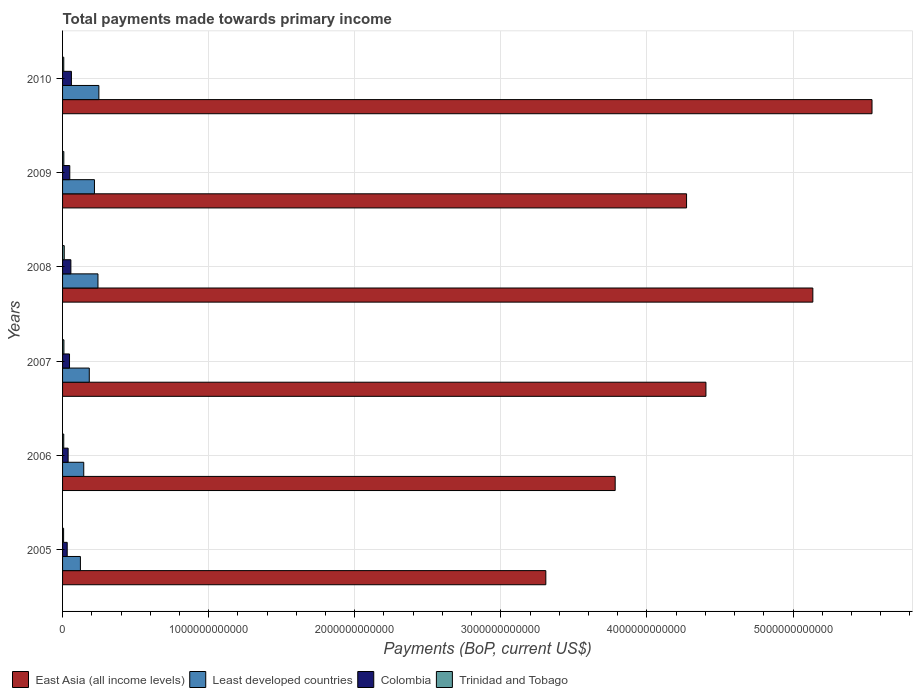How many different coloured bars are there?
Give a very brief answer. 4. How many groups of bars are there?
Give a very brief answer. 6. Are the number of bars on each tick of the Y-axis equal?
Your answer should be very brief. Yes. How many bars are there on the 6th tick from the bottom?
Your answer should be very brief. 4. What is the label of the 1st group of bars from the top?
Ensure brevity in your answer.  2010. What is the total payments made towards primary income in Colombia in 2009?
Your answer should be very brief. 4.93e+1. Across all years, what is the maximum total payments made towards primary income in Colombia?
Give a very brief answer. 6.07e+1. Across all years, what is the minimum total payments made towards primary income in Trinidad and Tobago?
Give a very brief answer. 7.13e+09. In which year was the total payments made towards primary income in East Asia (all income levels) minimum?
Provide a succinct answer. 2005. What is the total total payments made towards primary income in Least developed countries in the graph?
Provide a short and direct response. 1.16e+12. What is the difference between the total payments made towards primary income in East Asia (all income levels) in 2005 and that in 2009?
Your response must be concise. -9.63e+11. What is the difference between the total payments made towards primary income in Least developed countries in 2010 and the total payments made towards primary income in Trinidad and Tobago in 2008?
Provide a short and direct response. 2.37e+11. What is the average total payments made towards primary income in East Asia (all income levels) per year?
Ensure brevity in your answer.  4.41e+12. In the year 2006, what is the difference between the total payments made towards primary income in East Asia (all income levels) and total payments made towards primary income in Colombia?
Your response must be concise. 3.74e+12. In how many years, is the total payments made towards primary income in Colombia greater than 1400000000000 US$?
Provide a succinct answer. 0. What is the ratio of the total payments made towards primary income in Least developed countries in 2006 to that in 2007?
Your response must be concise. 0.79. Is the total payments made towards primary income in Colombia in 2005 less than that in 2009?
Keep it short and to the point. Yes. What is the difference between the highest and the second highest total payments made towards primary income in Trinidad and Tobago?
Offer a very short reply. 2.13e+09. What is the difference between the highest and the lowest total payments made towards primary income in Trinidad and Tobago?
Keep it short and to the point. 4.28e+09. Is the sum of the total payments made towards primary income in Colombia in 2005 and 2010 greater than the maximum total payments made towards primary income in Least developed countries across all years?
Your response must be concise. No. What does the 3rd bar from the top in 2007 represents?
Make the answer very short. Least developed countries. What does the 4th bar from the bottom in 2010 represents?
Offer a very short reply. Trinidad and Tobago. Is it the case that in every year, the sum of the total payments made towards primary income in Trinidad and Tobago and total payments made towards primary income in Least developed countries is greater than the total payments made towards primary income in East Asia (all income levels)?
Your answer should be compact. No. How many bars are there?
Provide a succinct answer. 24. How many years are there in the graph?
Provide a succinct answer. 6. What is the difference between two consecutive major ticks on the X-axis?
Ensure brevity in your answer.  1.00e+12. Are the values on the major ticks of X-axis written in scientific E-notation?
Provide a succinct answer. No. Does the graph contain any zero values?
Your answer should be compact. No. How many legend labels are there?
Provide a succinct answer. 4. What is the title of the graph?
Offer a terse response. Total payments made towards primary income. What is the label or title of the X-axis?
Ensure brevity in your answer.  Payments (BoP, current US$). What is the Payments (BoP, current US$) of East Asia (all income levels) in 2005?
Give a very brief answer. 3.31e+12. What is the Payments (BoP, current US$) of Least developed countries in 2005?
Your response must be concise. 1.22e+11. What is the Payments (BoP, current US$) of Colombia in 2005?
Your response must be concise. 3.18e+1. What is the Payments (BoP, current US$) in Trinidad and Tobago in 2005?
Make the answer very short. 7.13e+09. What is the Payments (BoP, current US$) in East Asia (all income levels) in 2006?
Your response must be concise. 3.78e+12. What is the Payments (BoP, current US$) of Least developed countries in 2006?
Your answer should be very brief. 1.45e+11. What is the Payments (BoP, current US$) in Colombia in 2006?
Provide a succinct answer. 3.81e+1. What is the Payments (BoP, current US$) of Trinidad and Tobago in 2006?
Offer a very short reply. 8.07e+09. What is the Payments (BoP, current US$) of East Asia (all income levels) in 2007?
Keep it short and to the point. 4.40e+12. What is the Payments (BoP, current US$) in Least developed countries in 2007?
Your answer should be very brief. 1.83e+11. What is the Payments (BoP, current US$) of Colombia in 2007?
Offer a very short reply. 4.76e+1. What is the Payments (BoP, current US$) in Trinidad and Tobago in 2007?
Provide a short and direct response. 9.28e+09. What is the Payments (BoP, current US$) in East Asia (all income levels) in 2008?
Offer a very short reply. 5.14e+12. What is the Payments (BoP, current US$) of Least developed countries in 2008?
Your answer should be compact. 2.42e+11. What is the Payments (BoP, current US$) in Colombia in 2008?
Ensure brevity in your answer.  5.69e+1. What is the Payments (BoP, current US$) in Trinidad and Tobago in 2008?
Offer a very short reply. 1.14e+1. What is the Payments (BoP, current US$) in East Asia (all income levels) in 2009?
Your answer should be compact. 4.27e+12. What is the Payments (BoP, current US$) in Least developed countries in 2009?
Offer a very short reply. 2.18e+11. What is the Payments (BoP, current US$) of Colombia in 2009?
Offer a very short reply. 4.93e+1. What is the Payments (BoP, current US$) in Trinidad and Tobago in 2009?
Your answer should be very brief. 8.66e+09. What is the Payments (BoP, current US$) of East Asia (all income levels) in 2010?
Provide a succinct answer. 5.54e+12. What is the Payments (BoP, current US$) of Least developed countries in 2010?
Give a very brief answer. 2.49e+11. What is the Payments (BoP, current US$) of Colombia in 2010?
Offer a terse response. 6.07e+1. What is the Payments (BoP, current US$) of Trinidad and Tobago in 2010?
Provide a short and direct response. 8.25e+09. Across all years, what is the maximum Payments (BoP, current US$) of East Asia (all income levels)?
Give a very brief answer. 5.54e+12. Across all years, what is the maximum Payments (BoP, current US$) of Least developed countries?
Give a very brief answer. 2.49e+11. Across all years, what is the maximum Payments (BoP, current US$) of Colombia?
Your answer should be compact. 6.07e+1. Across all years, what is the maximum Payments (BoP, current US$) in Trinidad and Tobago?
Your response must be concise. 1.14e+1. Across all years, what is the minimum Payments (BoP, current US$) in East Asia (all income levels)?
Your response must be concise. 3.31e+12. Across all years, what is the minimum Payments (BoP, current US$) in Least developed countries?
Your answer should be compact. 1.22e+11. Across all years, what is the minimum Payments (BoP, current US$) of Colombia?
Provide a succinct answer. 3.18e+1. Across all years, what is the minimum Payments (BoP, current US$) of Trinidad and Tobago?
Give a very brief answer. 7.13e+09. What is the total Payments (BoP, current US$) in East Asia (all income levels) in the graph?
Offer a very short reply. 2.64e+13. What is the total Payments (BoP, current US$) in Least developed countries in the graph?
Keep it short and to the point. 1.16e+12. What is the total Payments (BoP, current US$) in Colombia in the graph?
Give a very brief answer. 2.84e+11. What is the total Payments (BoP, current US$) in Trinidad and Tobago in the graph?
Keep it short and to the point. 5.28e+1. What is the difference between the Payments (BoP, current US$) in East Asia (all income levels) in 2005 and that in 2006?
Offer a very short reply. -4.75e+11. What is the difference between the Payments (BoP, current US$) of Least developed countries in 2005 and that in 2006?
Your answer should be compact. -2.29e+1. What is the difference between the Payments (BoP, current US$) of Colombia in 2005 and that in 2006?
Ensure brevity in your answer.  -6.36e+09. What is the difference between the Payments (BoP, current US$) in Trinidad and Tobago in 2005 and that in 2006?
Your answer should be compact. -9.40e+08. What is the difference between the Payments (BoP, current US$) of East Asia (all income levels) in 2005 and that in 2007?
Your answer should be compact. -1.10e+12. What is the difference between the Payments (BoP, current US$) of Least developed countries in 2005 and that in 2007?
Keep it short and to the point. -6.07e+1. What is the difference between the Payments (BoP, current US$) in Colombia in 2005 and that in 2007?
Offer a very short reply. -1.59e+1. What is the difference between the Payments (BoP, current US$) in Trinidad and Tobago in 2005 and that in 2007?
Ensure brevity in your answer.  -2.15e+09. What is the difference between the Payments (BoP, current US$) in East Asia (all income levels) in 2005 and that in 2008?
Your answer should be very brief. -1.83e+12. What is the difference between the Payments (BoP, current US$) in Least developed countries in 2005 and that in 2008?
Offer a very short reply. -1.20e+11. What is the difference between the Payments (BoP, current US$) of Colombia in 2005 and that in 2008?
Offer a very short reply. -2.52e+1. What is the difference between the Payments (BoP, current US$) in Trinidad and Tobago in 2005 and that in 2008?
Your answer should be compact. -4.28e+09. What is the difference between the Payments (BoP, current US$) in East Asia (all income levels) in 2005 and that in 2009?
Provide a succinct answer. -9.63e+11. What is the difference between the Payments (BoP, current US$) of Least developed countries in 2005 and that in 2009?
Offer a terse response. -9.62e+1. What is the difference between the Payments (BoP, current US$) of Colombia in 2005 and that in 2009?
Offer a terse response. -1.76e+1. What is the difference between the Payments (BoP, current US$) of Trinidad and Tobago in 2005 and that in 2009?
Provide a short and direct response. -1.53e+09. What is the difference between the Payments (BoP, current US$) of East Asia (all income levels) in 2005 and that in 2010?
Provide a short and direct response. -2.23e+12. What is the difference between the Payments (BoP, current US$) in Least developed countries in 2005 and that in 2010?
Offer a very short reply. -1.26e+11. What is the difference between the Payments (BoP, current US$) in Colombia in 2005 and that in 2010?
Ensure brevity in your answer.  -2.89e+1. What is the difference between the Payments (BoP, current US$) in Trinidad and Tobago in 2005 and that in 2010?
Provide a succinct answer. -1.12e+09. What is the difference between the Payments (BoP, current US$) of East Asia (all income levels) in 2006 and that in 2007?
Your answer should be very brief. -6.21e+11. What is the difference between the Payments (BoP, current US$) in Least developed countries in 2006 and that in 2007?
Offer a very short reply. -3.78e+1. What is the difference between the Payments (BoP, current US$) in Colombia in 2006 and that in 2007?
Your response must be concise. -9.51e+09. What is the difference between the Payments (BoP, current US$) in Trinidad and Tobago in 2006 and that in 2007?
Your answer should be very brief. -1.21e+09. What is the difference between the Payments (BoP, current US$) in East Asia (all income levels) in 2006 and that in 2008?
Offer a terse response. -1.35e+12. What is the difference between the Payments (BoP, current US$) in Least developed countries in 2006 and that in 2008?
Ensure brevity in your answer.  -9.73e+1. What is the difference between the Payments (BoP, current US$) of Colombia in 2006 and that in 2008?
Give a very brief answer. -1.88e+1. What is the difference between the Payments (BoP, current US$) in Trinidad and Tobago in 2006 and that in 2008?
Your answer should be compact. -3.34e+09. What is the difference between the Payments (BoP, current US$) in East Asia (all income levels) in 2006 and that in 2009?
Provide a short and direct response. -4.89e+11. What is the difference between the Payments (BoP, current US$) in Least developed countries in 2006 and that in 2009?
Offer a terse response. -7.33e+1. What is the difference between the Payments (BoP, current US$) of Colombia in 2006 and that in 2009?
Offer a very short reply. -1.12e+1. What is the difference between the Payments (BoP, current US$) of Trinidad and Tobago in 2006 and that in 2009?
Make the answer very short. -5.89e+08. What is the difference between the Payments (BoP, current US$) of East Asia (all income levels) in 2006 and that in 2010?
Make the answer very short. -1.76e+12. What is the difference between the Payments (BoP, current US$) in Least developed countries in 2006 and that in 2010?
Provide a short and direct response. -1.04e+11. What is the difference between the Payments (BoP, current US$) of Colombia in 2006 and that in 2010?
Make the answer very short. -2.25e+1. What is the difference between the Payments (BoP, current US$) in Trinidad and Tobago in 2006 and that in 2010?
Your answer should be very brief. -1.78e+08. What is the difference between the Payments (BoP, current US$) of East Asia (all income levels) in 2007 and that in 2008?
Offer a terse response. -7.32e+11. What is the difference between the Payments (BoP, current US$) in Least developed countries in 2007 and that in 2008?
Provide a short and direct response. -5.95e+1. What is the difference between the Payments (BoP, current US$) of Colombia in 2007 and that in 2008?
Provide a short and direct response. -9.30e+09. What is the difference between the Payments (BoP, current US$) in Trinidad and Tobago in 2007 and that in 2008?
Ensure brevity in your answer.  -2.13e+09. What is the difference between the Payments (BoP, current US$) in East Asia (all income levels) in 2007 and that in 2009?
Provide a succinct answer. 1.33e+11. What is the difference between the Payments (BoP, current US$) in Least developed countries in 2007 and that in 2009?
Offer a very short reply. -3.54e+1. What is the difference between the Payments (BoP, current US$) of Colombia in 2007 and that in 2009?
Your answer should be very brief. -1.72e+09. What is the difference between the Payments (BoP, current US$) of Trinidad and Tobago in 2007 and that in 2009?
Offer a very short reply. 6.22e+08. What is the difference between the Payments (BoP, current US$) in East Asia (all income levels) in 2007 and that in 2010?
Keep it short and to the point. -1.14e+12. What is the difference between the Payments (BoP, current US$) of Least developed countries in 2007 and that in 2010?
Provide a short and direct response. -6.57e+1. What is the difference between the Payments (BoP, current US$) of Colombia in 2007 and that in 2010?
Make the answer very short. -1.30e+1. What is the difference between the Payments (BoP, current US$) in Trinidad and Tobago in 2007 and that in 2010?
Your response must be concise. 1.03e+09. What is the difference between the Payments (BoP, current US$) in East Asia (all income levels) in 2008 and that in 2009?
Make the answer very short. 8.64e+11. What is the difference between the Payments (BoP, current US$) of Least developed countries in 2008 and that in 2009?
Offer a terse response. 2.40e+1. What is the difference between the Payments (BoP, current US$) in Colombia in 2008 and that in 2009?
Offer a very short reply. 7.58e+09. What is the difference between the Payments (BoP, current US$) in Trinidad and Tobago in 2008 and that in 2009?
Provide a short and direct response. 2.75e+09. What is the difference between the Payments (BoP, current US$) of East Asia (all income levels) in 2008 and that in 2010?
Keep it short and to the point. -4.05e+11. What is the difference between the Payments (BoP, current US$) in Least developed countries in 2008 and that in 2010?
Provide a short and direct response. -6.20e+09. What is the difference between the Payments (BoP, current US$) in Colombia in 2008 and that in 2010?
Your response must be concise. -3.73e+09. What is the difference between the Payments (BoP, current US$) of Trinidad and Tobago in 2008 and that in 2010?
Your answer should be very brief. 3.17e+09. What is the difference between the Payments (BoP, current US$) of East Asia (all income levels) in 2009 and that in 2010?
Your response must be concise. -1.27e+12. What is the difference between the Payments (BoP, current US$) in Least developed countries in 2009 and that in 2010?
Keep it short and to the point. -3.02e+1. What is the difference between the Payments (BoP, current US$) in Colombia in 2009 and that in 2010?
Your response must be concise. -1.13e+1. What is the difference between the Payments (BoP, current US$) in Trinidad and Tobago in 2009 and that in 2010?
Make the answer very short. 4.11e+08. What is the difference between the Payments (BoP, current US$) in East Asia (all income levels) in 2005 and the Payments (BoP, current US$) in Least developed countries in 2006?
Provide a short and direct response. 3.16e+12. What is the difference between the Payments (BoP, current US$) in East Asia (all income levels) in 2005 and the Payments (BoP, current US$) in Colombia in 2006?
Your answer should be very brief. 3.27e+12. What is the difference between the Payments (BoP, current US$) of East Asia (all income levels) in 2005 and the Payments (BoP, current US$) of Trinidad and Tobago in 2006?
Offer a very short reply. 3.30e+12. What is the difference between the Payments (BoP, current US$) of Least developed countries in 2005 and the Payments (BoP, current US$) of Colombia in 2006?
Ensure brevity in your answer.  8.40e+1. What is the difference between the Payments (BoP, current US$) of Least developed countries in 2005 and the Payments (BoP, current US$) of Trinidad and Tobago in 2006?
Offer a terse response. 1.14e+11. What is the difference between the Payments (BoP, current US$) in Colombia in 2005 and the Payments (BoP, current US$) in Trinidad and Tobago in 2006?
Provide a short and direct response. 2.37e+1. What is the difference between the Payments (BoP, current US$) in East Asia (all income levels) in 2005 and the Payments (BoP, current US$) in Least developed countries in 2007?
Give a very brief answer. 3.13e+12. What is the difference between the Payments (BoP, current US$) of East Asia (all income levels) in 2005 and the Payments (BoP, current US$) of Colombia in 2007?
Offer a very short reply. 3.26e+12. What is the difference between the Payments (BoP, current US$) in East Asia (all income levels) in 2005 and the Payments (BoP, current US$) in Trinidad and Tobago in 2007?
Keep it short and to the point. 3.30e+12. What is the difference between the Payments (BoP, current US$) in Least developed countries in 2005 and the Payments (BoP, current US$) in Colombia in 2007?
Make the answer very short. 7.45e+1. What is the difference between the Payments (BoP, current US$) in Least developed countries in 2005 and the Payments (BoP, current US$) in Trinidad and Tobago in 2007?
Your answer should be very brief. 1.13e+11. What is the difference between the Payments (BoP, current US$) in Colombia in 2005 and the Payments (BoP, current US$) in Trinidad and Tobago in 2007?
Your response must be concise. 2.25e+1. What is the difference between the Payments (BoP, current US$) in East Asia (all income levels) in 2005 and the Payments (BoP, current US$) in Least developed countries in 2008?
Make the answer very short. 3.07e+12. What is the difference between the Payments (BoP, current US$) of East Asia (all income levels) in 2005 and the Payments (BoP, current US$) of Colombia in 2008?
Ensure brevity in your answer.  3.25e+12. What is the difference between the Payments (BoP, current US$) of East Asia (all income levels) in 2005 and the Payments (BoP, current US$) of Trinidad and Tobago in 2008?
Provide a short and direct response. 3.30e+12. What is the difference between the Payments (BoP, current US$) in Least developed countries in 2005 and the Payments (BoP, current US$) in Colombia in 2008?
Provide a short and direct response. 6.52e+1. What is the difference between the Payments (BoP, current US$) of Least developed countries in 2005 and the Payments (BoP, current US$) of Trinidad and Tobago in 2008?
Give a very brief answer. 1.11e+11. What is the difference between the Payments (BoP, current US$) in Colombia in 2005 and the Payments (BoP, current US$) in Trinidad and Tobago in 2008?
Make the answer very short. 2.03e+1. What is the difference between the Payments (BoP, current US$) in East Asia (all income levels) in 2005 and the Payments (BoP, current US$) in Least developed countries in 2009?
Offer a very short reply. 3.09e+12. What is the difference between the Payments (BoP, current US$) of East Asia (all income levels) in 2005 and the Payments (BoP, current US$) of Colombia in 2009?
Give a very brief answer. 3.26e+12. What is the difference between the Payments (BoP, current US$) of East Asia (all income levels) in 2005 and the Payments (BoP, current US$) of Trinidad and Tobago in 2009?
Ensure brevity in your answer.  3.30e+12. What is the difference between the Payments (BoP, current US$) in Least developed countries in 2005 and the Payments (BoP, current US$) in Colombia in 2009?
Your answer should be compact. 7.28e+1. What is the difference between the Payments (BoP, current US$) in Least developed countries in 2005 and the Payments (BoP, current US$) in Trinidad and Tobago in 2009?
Ensure brevity in your answer.  1.13e+11. What is the difference between the Payments (BoP, current US$) in Colombia in 2005 and the Payments (BoP, current US$) in Trinidad and Tobago in 2009?
Provide a succinct answer. 2.31e+1. What is the difference between the Payments (BoP, current US$) of East Asia (all income levels) in 2005 and the Payments (BoP, current US$) of Least developed countries in 2010?
Give a very brief answer. 3.06e+12. What is the difference between the Payments (BoP, current US$) in East Asia (all income levels) in 2005 and the Payments (BoP, current US$) in Colombia in 2010?
Offer a terse response. 3.25e+12. What is the difference between the Payments (BoP, current US$) of East Asia (all income levels) in 2005 and the Payments (BoP, current US$) of Trinidad and Tobago in 2010?
Provide a short and direct response. 3.30e+12. What is the difference between the Payments (BoP, current US$) of Least developed countries in 2005 and the Payments (BoP, current US$) of Colombia in 2010?
Make the answer very short. 6.15e+1. What is the difference between the Payments (BoP, current US$) of Least developed countries in 2005 and the Payments (BoP, current US$) of Trinidad and Tobago in 2010?
Offer a terse response. 1.14e+11. What is the difference between the Payments (BoP, current US$) of Colombia in 2005 and the Payments (BoP, current US$) of Trinidad and Tobago in 2010?
Offer a very short reply. 2.35e+1. What is the difference between the Payments (BoP, current US$) in East Asia (all income levels) in 2006 and the Payments (BoP, current US$) in Least developed countries in 2007?
Keep it short and to the point. 3.60e+12. What is the difference between the Payments (BoP, current US$) of East Asia (all income levels) in 2006 and the Payments (BoP, current US$) of Colombia in 2007?
Provide a short and direct response. 3.74e+12. What is the difference between the Payments (BoP, current US$) of East Asia (all income levels) in 2006 and the Payments (BoP, current US$) of Trinidad and Tobago in 2007?
Your response must be concise. 3.77e+12. What is the difference between the Payments (BoP, current US$) in Least developed countries in 2006 and the Payments (BoP, current US$) in Colombia in 2007?
Your answer should be compact. 9.74e+1. What is the difference between the Payments (BoP, current US$) of Least developed countries in 2006 and the Payments (BoP, current US$) of Trinidad and Tobago in 2007?
Ensure brevity in your answer.  1.36e+11. What is the difference between the Payments (BoP, current US$) in Colombia in 2006 and the Payments (BoP, current US$) in Trinidad and Tobago in 2007?
Give a very brief answer. 2.88e+1. What is the difference between the Payments (BoP, current US$) of East Asia (all income levels) in 2006 and the Payments (BoP, current US$) of Least developed countries in 2008?
Your answer should be compact. 3.54e+12. What is the difference between the Payments (BoP, current US$) of East Asia (all income levels) in 2006 and the Payments (BoP, current US$) of Colombia in 2008?
Offer a very short reply. 3.73e+12. What is the difference between the Payments (BoP, current US$) in East Asia (all income levels) in 2006 and the Payments (BoP, current US$) in Trinidad and Tobago in 2008?
Offer a terse response. 3.77e+12. What is the difference between the Payments (BoP, current US$) in Least developed countries in 2006 and the Payments (BoP, current US$) in Colombia in 2008?
Your answer should be compact. 8.81e+1. What is the difference between the Payments (BoP, current US$) of Least developed countries in 2006 and the Payments (BoP, current US$) of Trinidad and Tobago in 2008?
Offer a terse response. 1.34e+11. What is the difference between the Payments (BoP, current US$) of Colombia in 2006 and the Payments (BoP, current US$) of Trinidad and Tobago in 2008?
Ensure brevity in your answer.  2.67e+1. What is the difference between the Payments (BoP, current US$) of East Asia (all income levels) in 2006 and the Payments (BoP, current US$) of Least developed countries in 2009?
Make the answer very short. 3.56e+12. What is the difference between the Payments (BoP, current US$) of East Asia (all income levels) in 2006 and the Payments (BoP, current US$) of Colombia in 2009?
Keep it short and to the point. 3.73e+12. What is the difference between the Payments (BoP, current US$) in East Asia (all income levels) in 2006 and the Payments (BoP, current US$) in Trinidad and Tobago in 2009?
Your answer should be compact. 3.77e+12. What is the difference between the Payments (BoP, current US$) of Least developed countries in 2006 and the Payments (BoP, current US$) of Colombia in 2009?
Ensure brevity in your answer.  9.57e+1. What is the difference between the Payments (BoP, current US$) of Least developed countries in 2006 and the Payments (BoP, current US$) of Trinidad and Tobago in 2009?
Your answer should be very brief. 1.36e+11. What is the difference between the Payments (BoP, current US$) of Colombia in 2006 and the Payments (BoP, current US$) of Trinidad and Tobago in 2009?
Offer a terse response. 2.95e+1. What is the difference between the Payments (BoP, current US$) of East Asia (all income levels) in 2006 and the Payments (BoP, current US$) of Least developed countries in 2010?
Your answer should be compact. 3.53e+12. What is the difference between the Payments (BoP, current US$) in East Asia (all income levels) in 2006 and the Payments (BoP, current US$) in Colombia in 2010?
Your response must be concise. 3.72e+12. What is the difference between the Payments (BoP, current US$) in East Asia (all income levels) in 2006 and the Payments (BoP, current US$) in Trinidad and Tobago in 2010?
Make the answer very short. 3.77e+12. What is the difference between the Payments (BoP, current US$) of Least developed countries in 2006 and the Payments (BoP, current US$) of Colombia in 2010?
Offer a terse response. 8.44e+1. What is the difference between the Payments (BoP, current US$) of Least developed countries in 2006 and the Payments (BoP, current US$) of Trinidad and Tobago in 2010?
Ensure brevity in your answer.  1.37e+11. What is the difference between the Payments (BoP, current US$) of Colombia in 2006 and the Payments (BoP, current US$) of Trinidad and Tobago in 2010?
Give a very brief answer. 2.99e+1. What is the difference between the Payments (BoP, current US$) of East Asia (all income levels) in 2007 and the Payments (BoP, current US$) of Least developed countries in 2008?
Make the answer very short. 4.16e+12. What is the difference between the Payments (BoP, current US$) in East Asia (all income levels) in 2007 and the Payments (BoP, current US$) in Colombia in 2008?
Your answer should be compact. 4.35e+12. What is the difference between the Payments (BoP, current US$) of East Asia (all income levels) in 2007 and the Payments (BoP, current US$) of Trinidad and Tobago in 2008?
Provide a succinct answer. 4.39e+12. What is the difference between the Payments (BoP, current US$) of Least developed countries in 2007 and the Payments (BoP, current US$) of Colombia in 2008?
Your answer should be very brief. 1.26e+11. What is the difference between the Payments (BoP, current US$) of Least developed countries in 2007 and the Payments (BoP, current US$) of Trinidad and Tobago in 2008?
Your response must be concise. 1.71e+11. What is the difference between the Payments (BoP, current US$) of Colombia in 2007 and the Payments (BoP, current US$) of Trinidad and Tobago in 2008?
Ensure brevity in your answer.  3.62e+1. What is the difference between the Payments (BoP, current US$) in East Asia (all income levels) in 2007 and the Payments (BoP, current US$) in Least developed countries in 2009?
Provide a short and direct response. 4.19e+12. What is the difference between the Payments (BoP, current US$) of East Asia (all income levels) in 2007 and the Payments (BoP, current US$) of Colombia in 2009?
Give a very brief answer. 4.35e+12. What is the difference between the Payments (BoP, current US$) in East Asia (all income levels) in 2007 and the Payments (BoP, current US$) in Trinidad and Tobago in 2009?
Offer a terse response. 4.40e+12. What is the difference between the Payments (BoP, current US$) in Least developed countries in 2007 and the Payments (BoP, current US$) in Colombia in 2009?
Provide a succinct answer. 1.34e+11. What is the difference between the Payments (BoP, current US$) in Least developed countries in 2007 and the Payments (BoP, current US$) in Trinidad and Tobago in 2009?
Ensure brevity in your answer.  1.74e+11. What is the difference between the Payments (BoP, current US$) of Colombia in 2007 and the Payments (BoP, current US$) of Trinidad and Tobago in 2009?
Make the answer very short. 3.90e+1. What is the difference between the Payments (BoP, current US$) in East Asia (all income levels) in 2007 and the Payments (BoP, current US$) in Least developed countries in 2010?
Your answer should be compact. 4.16e+12. What is the difference between the Payments (BoP, current US$) in East Asia (all income levels) in 2007 and the Payments (BoP, current US$) in Colombia in 2010?
Provide a short and direct response. 4.34e+12. What is the difference between the Payments (BoP, current US$) of East Asia (all income levels) in 2007 and the Payments (BoP, current US$) of Trinidad and Tobago in 2010?
Ensure brevity in your answer.  4.40e+12. What is the difference between the Payments (BoP, current US$) of Least developed countries in 2007 and the Payments (BoP, current US$) of Colombia in 2010?
Your response must be concise. 1.22e+11. What is the difference between the Payments (BoP, current US$) in Least developed countries in 2007 and the Payments (BoP, current US$) in Trinidad and Tobago in 2010?
Provide a short and direct response. 1.75e+11. What is the difference between the Payments (BoP, current US$) in Colombia in 2007 and the Payments (BoP, current US$) in Trinidad and Tobago in 2010?
Provide a short and direct response. 3.94e+1. What is the difference between the Payments (BoP, current US$) of East Asia (all income levels) in 2008 and the Payments (BoP, current US$) of Least developed countries in 2009?
Ensure brevity in your answer.  4.92e+12. What is the difference between the Payments (BoP, current US$) in East Asia (all income levels) in 2008 and the Payments (BoP, current US$) in Colombia in 2009?
Keep it short and to the point. 5.09e+12. What is the difference between the Payments (BoP, current US$) of East Asia (all income levels) in 2008 and the Payments (BoP, current US$) of Trinidad and Tobago in 2009?
Make the answer very short. 5.13e+12. What is the difference between the Payments (BoP, current US$) of Least developed countries in 2008 and the Payments (BoP, current US$) of Colombia in 2009?
Ensure brevity in your answer.  1.93e+11. What is the difference between the Payments (BoP, current US$) of Least developed countries in 2008 and the Payments (BoP, current US$) of Trinidad and Tobago in 2009?
Give a very brief answer. 2.34e+11. What is the difference between the Payments (BoP, current US$) in Colombia in 2008 and the Payments (BoP, current US$) in Trinidad and Tobago in 2009?
Offer a very short reply. 4.83e+1. What is the difference between the Payments (BoP, current US$) of East Asia (all income levels) in 2008 and the Payments (BoP, current US$) of Least developed countries in 2010?
Give a very brief answer. 4.89e+12. What is the difference between the Payments (BoP, current US$) in East Asia (all income levels) in 2008 and the Payments (BoP, current US$) in Colombia in 2010?
Your answer should be very brief. 5.08e+12. What is the difference between the Payments (BoP, current US$) of East Asia (all income levels) in 2008 and the Payments (BoP, current US$) of Trinidad and Tobago in 2010?
Provide a short and direct response. 5.13e+12. What is the difference between the Payments (BoP, current US$) in Least developed countries in 2008 and the Payments (BoP, current US$) in Colombia in 2010?
Ensure brevity in your answer.  1.82e+11. What is the difference between the Payments (BoP, current US$) of Least developed countries in 2008 and the Payments (BoP, current US$) of Trinidad and Tobago in 2010?
Your answer should be very brief. 2.34e+11. What is the difference between the Payments (BoP, current US$) of Colombia in 2008 and the Payments (BoP, current US$) of Trinidad and Tobago in 2010?
Make the answer very short. 4.87e+1. What is the difference between the Payments (BoP, current US$) in East Asia (all income levels) in 2009 and the Payments (BoP, current US$) in Least developed countries in 2010?
Your response must be concise. 4.02e+12. What is the difference between the Payments (BoP, current US$) of East Asia (all income levels) in 2009 and the Payments (BoP, current US$) of Colombia in 2010?
Provide a succinct answer. 4.21e+12. What is the difference between the Payments (BoP, current US$) in East Asia (all income levels) in 2009 and the Payments (BoP, current US$) in Trinidad and Tobago in 2010?
Provide a succinct answer. 4.26e+12. What is the difference between the Payments (BoP, current US$) in Least developed countries in 2009 and the Payments (BoP, current US$) in Colombia in 2010?
Provide a short and direct response. 1.58e+11. What is the difference between the Payments (BoP, current US$) of Least developed countries in 2009 and the Payments (BoP, current US$) of Trinidad and Tobago in 2010?
Your answer should be very brief. 2.10e+11. What is the difference between the Payments (BoP, current US$) in Colombia in 2009 and the Payments (BoP, current US$) in Trinidad and Tobago in 2010?
Your response must be concise. 4.11e+1. What is the average Payments (BoP, current US$) in East Asia (all income levels) per year?
Your answer should be very brief. 4.41e+12. What is the average Payments (BoP, current US$) of Least developed countries per year?
Offer a terse response. 1.93e+11. What is the average Payments (BoP, current US$) in Colombia per year?
Offer a very short reply. 4.74e+1. What is the average Payments (BoP, current US$) of Trinidad and Tobago per year?
Provide a short and direct response. 8.80e+09. In the year 2005, what is the difference between the Payments (BoP, current US$) of East Asia (all income levels) and Payments (BoP, current US$) of Least developed countries?
Offer a terse response. 3.19e+12. In the year 2005, what is the difference between the Payments (BoP, current US$) of East Asia (all income levels) and Payments (BoP, current US$) of Colombia?
Give a very brief answer. 3.28e+12. In the year 2005, what is the difference between the Payments (BoP, current US$) in East Asia (all income levels) and Payments (BoP, current US$) in Trinidad and Tobago?
Provide a succinct answer. 3.30e+12. In the year 2005, what is the difference between the Payments (BoP, current US$) of Least developed countries and Payments (BoP, current US$) of Colombia?
Your response must be concise. 9.04e+1. In the year 2005, what is the difference between the Payments (BoP, current US$) in Least developed countries and Payments (BoP, current US$) in Trinidad and Tobago?
Ensure brevity in your answer.  1.15e+11. In the year 2005, what is the difference between the Payments (BoP, current US$) of Colombia and Payments (BoP, current US$) of Trinidad and Tobago?
Ensure brevity in your answer.  2.46e+1. In the year 2006, what is the difference between the Payments (BoP, current US$) in East Asia (all income levels) and Payments (BoP, current US$) in Least developed countries?
Your answer should be very brief. 3.64e+12. In the year 2006, what is the difference between the Payments (BoP, current US$) in East Asia (all income levels) and Payments (BoP, current US$) in Colombia?
Keep it short and to the point. 3.74e+12. In the year 2006, what is the difference between the Payments (BoP, current US$) in East Asia (all income levels) and Payments (BoP, current US$) in Trinidad and Tobago?
Offer a very short reply. 3.77e+12. In the year 2006, what is the difference between the Payments (BoP, current US$) of Least developed countries and Payments (BoP, current US$) of Colombia?
Your answer should be compact. 1.07e+11. In the year 2006, what is the difference between the Payments (BoP, current US$) of Least developed countries and Payments (BoP, current US$) of Trinidad and Tobago?
Offer a very short reply. 1.37e+11. In the year 2006, what is the difference between the Payments (BoP, current US$) in Colombia and Payments (BoP, current US$) in Trinidad and Tobago?
Your response must be concise. 3.00e+1. In the year 2007, what is the difference between the Payments (BoP, current US$) in East Asia (all income levels) and Payments (BoP, current US$) in Least developed countries?
Provide a succinct answer. 4.22e+12. In the year 2007, what is the difference between the Payments (BoP, current US$) of East Asia (all income levels) and Payments (BoP, current US$) of Colombia?
Ensure brevity in your answer.  4.36e+12. In the year 2007, what is the difference between the Payments (BoP, current US$) of East Asia (all income levels) and Payments (BoP, current US$) of Trinidad and Tobago?
Provide a short and direct response. 4.39e+12. In the year 2007, what is the difference between the Payments (BoP, current US$) in Least developed countries and Payments (BoP, current US$) in Colombia?
Your answer should be very brief. 1.35e+11. In the year 2007, what is the difference between the Payments (BoP, current US$) in Least developed countries and Payments (BoP, current US$) in Trinidad and Tobago?
Give a very brief answer. 1.74e+11. In the year 2007, what is the difference between the Payments (BoP, current US$) of Colombia and Payments (BoP, current US$) of Trinidad and Tobago?
Your response must be concise. 3.83e+1. In the year 2008, what is the difference between the Payments (BoP, current US$) of East Asia (all income levels) and Payments (BoP, current US$) of Least developed countries?
Offer a terse response. 4.89e+12. In the year 2008, what is the difference between the Payments (BoP, current US$) of East Asia (all income levels) and Payments (BoP, current US$) of Colombia?
Offer a very short reply. 5.08e+12. In the year 2008, what is the difference between the Payments (BoP, current US$) in East Asia (all income levels) and Payments (BoP, current US$) in Trinidad and Tobago?
Offer a terse response. 5.12e+12. In the year 2008, what is the difference between the Payments (BoP, current US$) of Least developed countries and Payments (BoP, current US$) of Colombia?
Your response must be concise. 1.85e+11. In the year 2008, what is the difference between the Payments (BoP, current US$) of Least developed countries and Payments (BoP, current US$) of Trinidad and Tobago?
Provide a short and direct response. 2.31e+11. In the year 2008, what is the difference between the Payments (BoP, current US$) of Colombia and Payments (BoP, current US$) of Trinidad and Tobago?
Make the answer very short. 4.55e+1. In the year 2009, what is the difference between the Payments (BoP, current US$) in East Asia (all income levels) and Payments (BoP, current US$) in Least developed countries?
Make the answer very short. 4.05e+12. In the year 2009, what is the difference between the Payments (BoP, current US$) in East Asia (all income levels) and Payments (BoP, current US$) in Colombia?
Offer a very short reply. 4.22e+12. In the year 2009, what is the difference between the Payments (BoP, current US$) in East Asia (all income levels) and Payments (BoP, current US$) in Trinidad and Tobago?
Ensure brevity in your answer.  4.26e+12. In the year 2009, what is the difference between the Payments (BoP, current US$) of Least developed countries and Payments (BoP, current US$) of Colombia?
Your response must be concise. 1.69e+11. In the year 2009, what is the difference between the Payments (BoP, current US$) of Least developed countries and Payments (BoP, current US$) of Trinidad and Tobago?
Give a very brief answer. 2.10e+11. In the year 2009, what is the difference between the Payments (BoP, current US$) of Colombia and Payments (BoP, current US$) of Trinidad and Tobago?
Offer a terse response. 4.07e+1. In the year 2010, what is the difference between the Payments (BoP, current US$) in East Asia (all income levels) and Payments (BoP, current US$) in Least developed countries?
Give a very brief answer. 5.29e+12. In the year 2010, what is the difference between the Payments (BoP, current US$) of East Asia (all income levels) and Payments (BoP, current US$) of Colombia?
Your response must be concise. 5.48e+12. In the year 2010, what is the difference between the Payments (BoP, current US$) of East Asia (all income levels) and Payments (BoP, current US$) of Trinidad and Tobago?
Your answer should be compact. 5.53e+12. In the year 2010, what is the difference between the Payments (BoP, current US$) of Least developed countries and Payments (BoP, current US$) of Colombia?
Offer a terse response. 1.88e+11. In the year 2010, what is the difference between the Payments (BoP, current US$) in Least developed countries and Payments (BoP, current US$) in Trinidad and Tobago?
Ensure brevity in your answer.  2.40e+11. In the year 2010, what is the difference between the Payments (BoP, current US$) of Colombia and Payments (BoP, current US$) of Trinidad and Tobago?
Provide a short and direct response. 5.24e+1. What is the ratio of the Payments (BoP, current US$) of East Asia (all income levels) in 2005 to that in 2006?
Your answer should be compact. 0.87. What is the ratio of the Payments (BoP, current US$) of Least developed countries in 2005 to that in 2006?
Give a very brief answer. 0.84. What is the ratio of the Payments (BoP, current US$) in Colombia in 2005 to that in 2006?
Offer a very short reply. 0.83. What is the ratio of the Payments (BoP, current US$) in Trinidad and Tobago in 2005 to that in 2006?
Give a very brief answer. 0.88. What is the ratio of the Payments (BoP, current US$) in East Asia (all income levels) in 2005 to that in 2007?
Make the answer very short. 0.75. What is the ratio of the Payments (BoP, current US$) of Least developed countries in 2005 to that in 2007?
Provide a succinct answer. 0.67. What is the ratio of the Payments (BoP, current US$) in Colombia in 2005 to that in 2007?
Your answer should be very brief. 0.67. What is the ratio of the Payments (BoP, current US$) of Trinidad and Tobago in 2005 to that in 2007?
Your response must be concise. 0.77. What is the ratio of the Payments (BoP, current US$) in East Asia (all income levels) in 2005 to that in 2008?
Make the answer very short. 0.64. What is the ratio of the Payments (BoP, current US$) in Least developed countries in 2005 to that in 2008?
Ensure brevity in your answer.  0.5. What is the ratio of the Payments (BoP, current US$) in Colombia in 2005 to that in 2008?
Provide a short and direct response. 0.56. What is the ratio of the Payments (BoP, current US$) of Trinidad and Tobago in 2005 to that in 2008?
Provide a short and direct response. 0.62. What is the ratio of the Payments (BoP, current US$) of East Asia (all income levels) in 2005 to that in 2009?
Provide a succinct answer. 0.77. What is the ratio of the Payments (BoP, current US$) in Least developed countries in 2005 to that in 2009?
Provide a short and direct response. 0.56. What is the ratio of the Payments (BoP, current US$) in Colombia in 2005 to that in 2009?
Your answer should be very brief. 0.64. What is the ratio of the Payments (BoP, current US$) in Trinidad and Tobago in 2005 to that in 2009?
Offer a terse response. 0.82. What is the ratio of the Payments (BoP, current US$) of East Asia (all income levels) in 2005 to that in 2010?
Ensure brevity in your answer.  0.6. What is the ratio of the Payments (BoP, current US$) in Least developed countries in 2005 to that in 2010?
Your response must be concise. 0.49. What is the ratio of the Payments (BoP, current US$) in Colombia in 2005 to that in 2010?
Keep it short and to the point. 0.52. What is the ratio of the Payments (BoP, current US$) of Trinidad and Tobago in 2005 to that in 2010?
Ensure brevity in your answer.  0.86. What is the ratio of the Payments (BoP, current US$) in East Asia (all income levels) in 2006 to that in 2007?
Ensure brevity in your answer.  0.86. What is the ratio of the Payments (BoP, current US$) in Least developed countries in 2006 to that in 2007?
Ensure brevity in your answer.  0.79. What is the ratio of the Payments (BoP, current US$) of Colombia in 2006 to that in 2007?
Provide a short and direct response. 0.8. What is the ratio of the Payments (BoP, current US$) in Trinidad and Tobago in 2006 to that in 2007?
Your response must be concise. 0.87. What is the ratio of the Payments (BoP, current US$) in East Asia (all income levels) in 2006 to that in 2008?
Keep it short and to the point. 0.74. What is the ratio of the Payments (BoP, current US$) in Least developed countries in 2006 to that in 2008?
Your response must be concise. 0.6. What is the ratio of the Payments (BoP, current US$) in Colombia in 2006 to that in 2008?
Keep it short and to the point. 0.67. What is the ratio of the Payments (BoP, current US$) in Trinidad and Tobago in 2006 to that in 2008?
Offer a terse response. 0.71. What is the ratio of the Payments (BoP, current US$) of East Asia (all income levels) in 2006 to that in 2009?
Your answer should be compact. 0.89. What is the ratio of the Payments (BoP, current US$) of Least developed countries in 2006 to that in 2009?
Ensure brevity in your answer.  0.66. What is the ratio of the Payments (BoP, current US$) of Colombia in 2006 to that in 2009?
Give a very brief answer. 0.77. What is the ratio of the Payments (BoP, current US$) of Trinidad and Tobago in 2006 to that in 2009?
Offer a very short reply. 0.93. What is the ratio of the Payments (BoP, current US$) of East Asia (all income levels) in 2006 to that in 2010?
Offer a terse response. 0.68. What is the ratio of the Payments (BoP, current US$) of Least developed countries in 2006 to that in 2010?
Your answer should be compact. 0.58. What is the ratio of the Payments (BoP, current US$) in Colombia in 2006 to that in 2010?
Offer a very short reply. 0.63. What is the ratio of the Payments (BoP, current US$) in Trinidad and Tobago in 2006 to that in 2010?
Make the answer very short. 0.98. What is the ratio of the Payments (BoP, current US$) in East Asia (all income levels) in 2007 to that in 2008?
Provide a short and direct response. 0.86. What is the ratio of the Payments (BoP, current US$) of Least developed countries in 2007 to that in 2008?
Your answer should be compact. 0.75. What is the ratio of the Payments (BoP, current US$) of Colombia in 2007 to that in 2008?
Offer a terse response. 0.84. What is the ratio of the Payments (BoP, current US$) of Trinidad and Tobago in 2007 to that in 2008?
Make the answer very short. 0.81. What is the ratio of the Payments (BoP, current US$) of East Asia (all income levels) in 2007 to that in 2009?
Provide a short and direct response. 1.03. What is the ratio of the Payments (BoP, current US$) in Least developed countries in 2007 to that in 2009?
Offer a very short reply. 0.84. What is the ratio of the Payments (BoP, current US$) in Colombia in 2007 to that in 2009?
Your answer should be very brief. 0.97. What is the ratio of the Payments (BoP, current US$) in Trinidad and Tobago in 2007 to that in 2009?
Offer a terse response. 1.07. What is the ratio of the Payments (BoP, current US$) in East Asia (all income levels) in 2007 to that in 2010?
Make the answer very short. 0.79. What is the ratio of the Payments (BoP, current US$) of Least developed countries in 2007 to that in 2010?
Make the answer very short. 0.74. What is the ratio of the Payments (BoP, current US$) of Colombia in 2007 to that in 2010?
Your answer should be very brief. 0.79. What is the ratio of the Payments (BoP, current US$) in Trinidad and Tobago in 2007 to that in 2010?
Your answer should be very brief. 1.13. What is the ratio of the Payments (BoP, current US$) in East Asia (all income levels) in 2008 to that in 2009?
Offer a very short reply. 1.2. What is the ratio of the Payments (BoP, current US$) in Least developed countries in 2008 to that in 2009?
Offer a very short reply. 1.11. What is the ratio of the Payments (BoP, current US$) in Colombia in 2008 to that in 2009?
Your answer should be very brief. 1.15. What is the ratio of the Payments (BoP, current US$) of Trinidad and Tobago in 2008 to that in 2009?
Provide a succinct answer. 1.32. What is the ratio of the Payments (BoP, current US$) in East Asia (all income levels) in 2008 to that in 2010?
Offer a terse response. 0.93. What is the ratio of the Payments (BoP, current US$) in Least developed countries in 2008 to that in 2010?
Provide a short and direct response. 0.97. What is the ratio of the Payments (BoP, current US$) in Colombia in 2008 to that in 2010?
Your response must be concise. 0.94. What is the ratio of the Payments (BoP, current US$) of Trinidad and Tobago in 2008 to that in 2010?
Your answer should be very brief. 1.38. What is the ratio of the Payments (BoP, current US$) in East Asia (all income levels) in 2009 to that in 2010?
Provide a succinct answer. 0.77. What is the ratio of the Payments (BoP, current US$) in Least developed countries in 2009 to that in 2010?
Make the answer very short. 0.88. What is the ratio of the Payments (BoP, current US$) in Colombia in 2009 to that in 2010?
Provide a short and direct response. 0.81. What is the ratio of the Payments (BoP, current US$) of Trinidad and Tobago in 2009 to that in 2010?
Provide a short and direct response. 1.05. What is the difference between the highest and the second highest Payments (BoP, current US$) of East Asia (all income levels)?
Your answer should be very brief. 4.05e+11. What is the difference between the highest and the second highest Payments (BoP, current US$) in Least developed countries?
Provide a succinct answer. 6.20e+09. What is the difference between the highest and the second highest Payments (BoP, current US$) of Colombia?
Give a very brief answer. 3.73e+09. What is the difference between the highest and the second highest Payments (BoP, current US$) of Trinidad and Tobago?
Offer a terse response. 2.13e+09. What is the difference between the highest and the lowest Payments (BoP, current US$) of East Asia (all income levels)?
Ensure brevity in your answer.  2.23e+12. What is the difference between the highest and the lowest Payments (BoP, current US$) of Least developed countries?
Provide a short and direct response. 1.26e+11. What is the difference between the highest and the lowest Payments (BoP, current US$) in Colombia?
Offer a terse response. 2.89e+1. What is the difference between the highest and the lowest Payments (BoP, current US$) in Trinidad and Tobago?
Provide a short and direct response. 4.28e+09. 